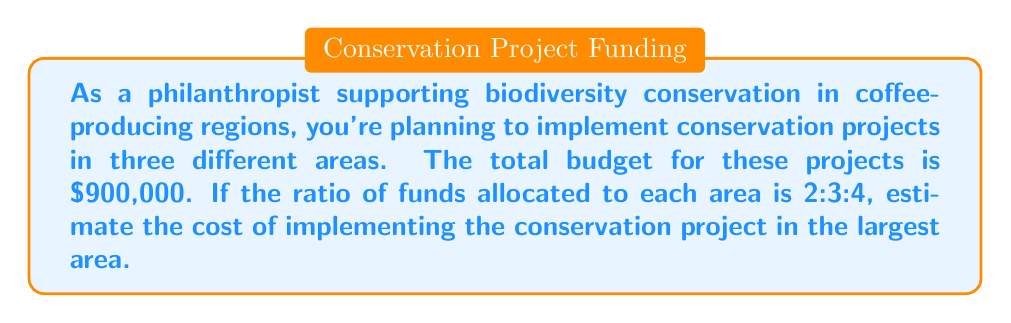What is the answer to this math problem? Let's approach this step-by-step:

1) First, we need to understand what the ratio 2:3:4 means. It tells us the relative proportion of funds allocated to each area. The total parts in the ratio is:

   $2 + 3 + 4 = 9$ parts

2) The largest area corresponds to the largest number in the ratio, which is 4.

3) To find the fraction of the total budget that goes to the largest area, we divide its parts by the total parts:

   $\frac{4}{9}$ of the total budget

4) Now, let's calculate this fraction of the total budget:

   $$\frac{4}{9} \times $900,000 = $400,000$$

Therefore, the cost of implementing the conservation project in the largest area can be estimated as $400,000.
Answer: $400,000 